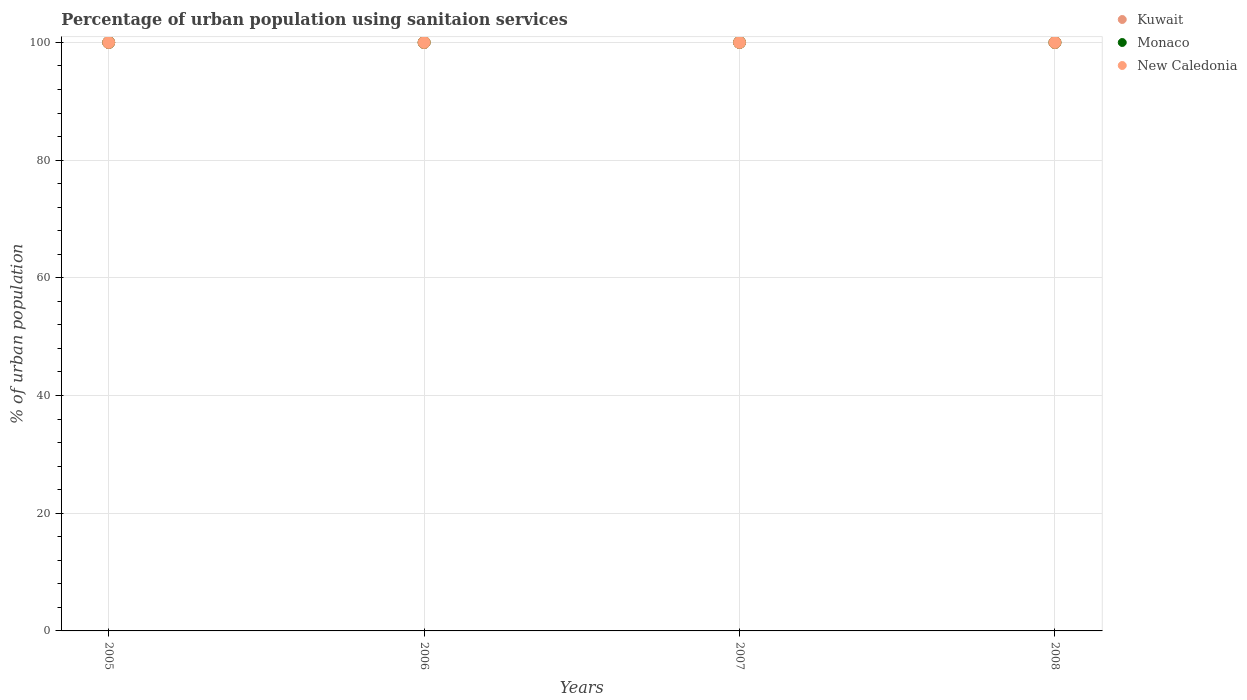What is the percentage of urban population using sanitaion services in Monaco in 2007?
Make the answer very short. 100. Across all years, what is the maximum percentage of urban population using sanitaion services in Kuwait?
Your response must be concise. 100. Across all years, what is the minimum percentage of urban population using sanitaion services in Kuwait?
Your response must be concise. 100. In which year was the percentage of urban population using sanitaion services in Monaco maximum?
Your answer should be very brief. 2005. What is the total percentage of urban population using sanitaion services in Kuwait in the graph?
Provide a short and direct response. 400. What is the difference between the percentage of urban population using sanitaion services in Monaco in 2006 and that in 2007?
Keep it short and to the point. 0. What is the difference between the percentage of urban population using sanitaion services in Kuwait in 2005 and the percentage of urban population using sanitaion services in Monaco in 2007?
Ensure brevity in your answer.  0. Is the difference between the percentage of urban population using sanitaion services in Kuwait in 2005 and 2006 greater than the difference between the percentage of urban population using sanitaion services in Monaco in 2005 and 2006?
Ensure brevity in your answer.  No. What is the difference between the highest and the second highest percentage of urban population using sanitaion services in New Caledonia?
Your answer should be very brief. 0. What is the difference between the highest and the lowest percentage of urban population using sanitaion services in Monaco?
Ensure brevity in your answer.  0. Is the sum of the percentage of urban population using sanitaion services in Monaco in 2005 and 2008 greater than the maximum percentage of urban population using sanitaion services in New Caledonia across all years?
Give a very brief answer. Yes. Is the percentage of urban population using sanitaion services in Monaco strictly less than the percentage of urban population using sanitaion services in New Caledonia over the years?
Ensure brevity in your answer.  No. What is the difference between two consecutive major ticks on the Y-axis?
Offer a terse response. 20. Are the values on the major ticks of Y-axis written in scientific E-notation?
Your answer should be compact. No. Where does the legend appear in the graph?
Offer a very short reply. Top right. How are the legend labels stacked?
Provide a short and direct response. Vertical. What is the title of the graph?
Provide a short and direct response. Percentage of urban population using sanitaion services. What is the label or title of the X-axis?
Offer a terse response. Years. What is the label or title of the Y-axis?
Offer a terse response. % of urban population. What is the % of urban population of Kuwait in 2005?
Keep it short and to the point. 100. What is the % of urban population in Monaco in 2005?
Keep it short and to the point. 100. What is the % of urban population in New Caledonia in 2005?
Offer a terse response. 100. What is the % of urban population of Monaco in 2006?
Your answer should be very brief. 100. What is the % of urban population of New Caledonia in 2006?
Provide a succinct answer. 100. What is the % of urban population of Kuwait in 2007?
Provide a succinct answer. 100. What is the % of urban population of New Caledonia in 2007?
Provide a short and direct response. 100. What is the % of urban population of Kuwait in 2008?
Ensure brevity in your answer.  100. What is the % of urban population of New Caledonia in 2008?
Make the answer very short. 100. Across all years, what is the minimum % of urban population in Monaco?
Offer a very short reply. 100. Across all years, what is the minimum % of urban population of New Caledonia?
Provide a short and direct response. 100. What is the total % of urban population in Monaco in the graph?
Offer a terse response. 400. What is the difference between the % of urban population of Kuwait in 2005 and that in 2007?
Make the answer very short. 0. What is the difference between the % of urban population in New Caledonia in 2005 and that in 2007?
Give a very brief answer. 0. What is the difference between the % of urban population of New Caledonia in 2005 and that in 2008?
Offer a very short reply. 0. What is the difference between the % of urban population in Kuwait in 2006 and that in 2007?
Your answer should be compact. 0. What is the difference between the % of urban population in New Caledonia in 2006 and that in 2008?
Keep it short and to the point. 0. What is the difference between the % of urban population in Kuwait in 2007 and that in 2008?
Ensure brevity in your answer.  0. What is the difference between the % of urban population in Monaco in 2007 and that in 2008?
Provide a succinct answer. 0. What is the difference between the % of urban population in New Caledonia in 2007 and that in 2008?
Your response must be concise. 0. What is the difference between the % of urban population of Monaco in 2005 and the % of urban population of New Caledonia in 2006?
Your response must be concise. 0. What is the difference between the % of urban population of Kuwait in 2005 and the % of urban population of Monaco in 2007?
Your response must be concise. 0. What is the difference between the % of urban population of Kuwait in 2005 and the % of urban population of Monaco in 2008?
Your answer should be compact. 0. What is the difference between the % of urban population in Kuwait in 2005 and the % of urban population in New Caledonia in 2008?
Offer a very short reply. 0. What is the difference between the % of urban population in Kuwait in 2006 and the % of urban population in Monaco in 2007?
Provide a succinct answer. 0. What is the difference between the % of urban population of Kuwait in 2006 and the % of urban population of New Caledonia in 2007?
Your response must be concise. 0. What is the difference between the % of urban population in Monaco in 2006 and the % of urban population in New Caledonia in 2008?
Keep it short and to the point. 0. What is the difference between the % of urban population of Kuwait in 2007 and the % of urban population of New Caledonia in 2008?
Provide a short and direct response. 0. What is the average % of urban population in New Caledonia per year?
Offer a very short reply. 100. In the year 2006, what is the difference between the % of urban population in Kuwait and % of urban population in Monaco?
Your response must be concise. 0. In the year 2006, what is the difference between the % of urban population of Kuwait and % of urban population of New Caledonia?
Make the answer very short. 0. In the year 2006, what is the difference between the % of urban population in Monaco and % of urban population in New Caledonia?
Your answer should be very brief. 0. In the year 2007, what is the difference between the % of urban population in Monaco and % of urban population in New Caledonia?
Give a very brief answer. 0. In the year 2008, what is the difference between the % of urban population of Kuwait and % of urban population of Monaco?
Your answer should be very brief. 0. In the year 2008, what is the difference between the % of urban population in Monaco and % of urban population in New Caledonia?
Provide a succinct answer. 0. What is the ratio of the % of urban population in New Caledonia in 2005 to that in 2007?
Make the answer very short. 1. What is the ratio of the % of urban population of New Caledonia in 2005 to that in 2008?
Offer a very short reply. 1. What is the ratio of the % of urban population in Monaco in 2006 to that in 2007?
Your answer should be compact. 1. What is the ratio of the % of urban population in Monaco in 2007 to that in 2008?
Ensure brevity in your answer.  1. What is the ratio of the % of urban population in New Caledonia in 2007 to that in 2008?
Keep it short and to the point. 1. What is the difference between the highest and the second highest % of urban population in Kuwait?
Give a very brief answer. 0. What is the difference between the highest and the second highest % of urban population of Monaco?
Your answer should be compact. 0. What is the difference between the highest and the second highest % of urban population in New Caledonia?
Ensure brevity in your answer.  0. 